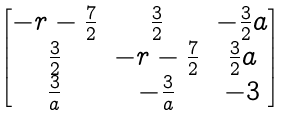<formula> <loc_0><loc_0><loc_500><loc_500>\begin{bmatrix} - r - \frac { 7 } { 2 } & \frac { 3 } { 2 } & - \frac { 3 } { 2 } a \\ \frac { 3 } { 2 } & - r - \frac { 7 } { 2 } & \frac { 3 } { 2 } a \\ \frac { 3 } { a } & - \frac { 3 } { a } & - 3 \end{bmatrix}</formula> 